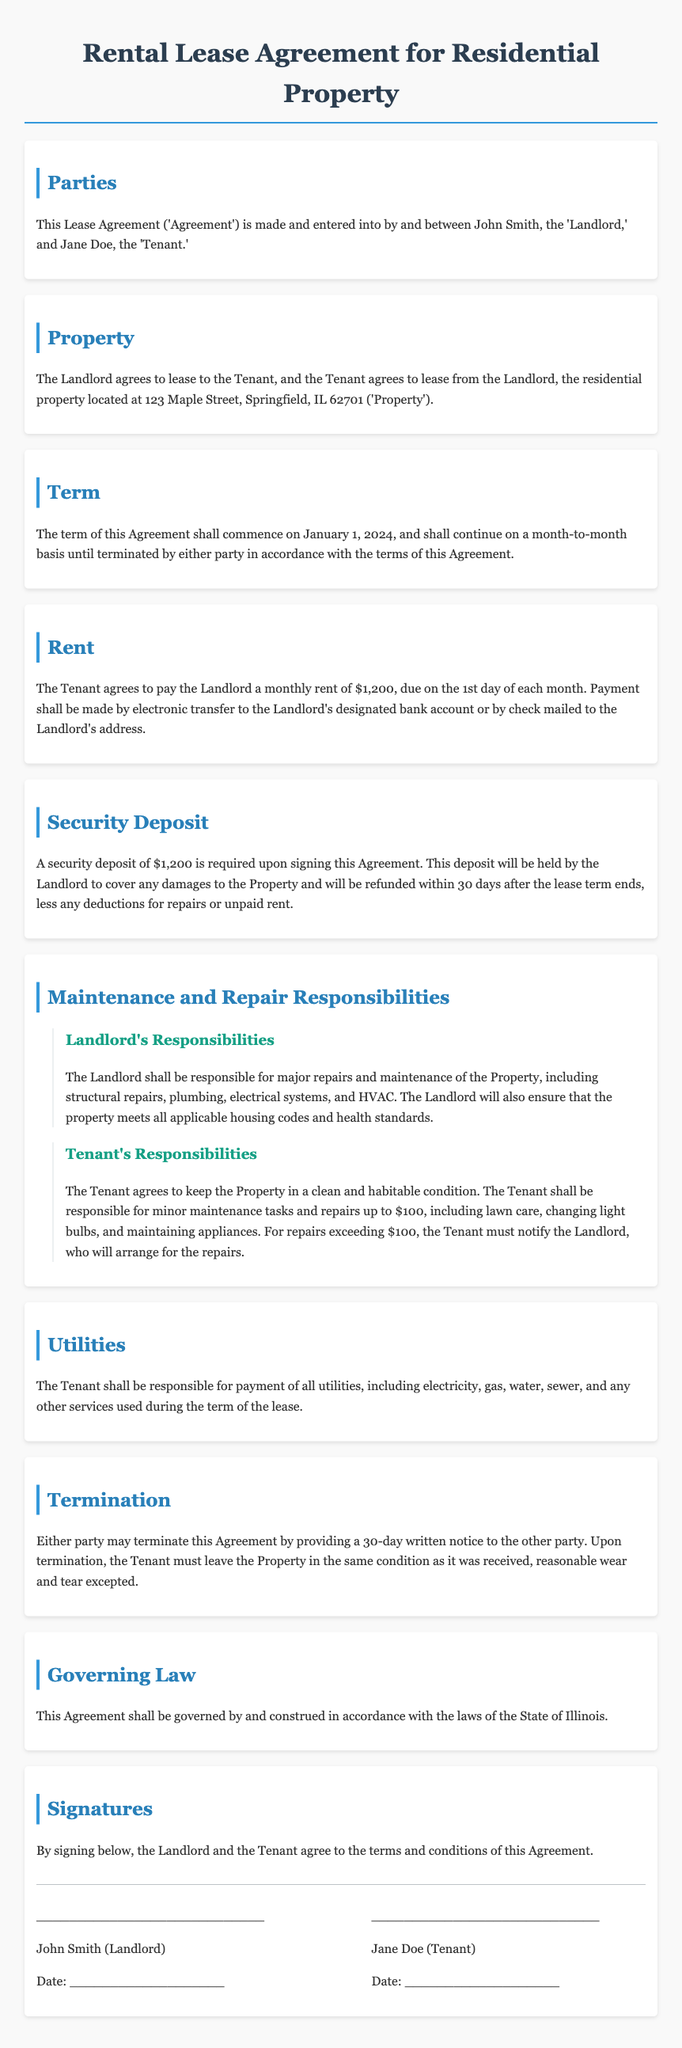What is the rental amount? The rental amount is specified in the Rent section of the document as $1,200.
Answer: $1,200 Who are the parties involved in the agreement? The parties involved are listed in the Parties section as John Smith and Jane Doe.
Answer: John Smith and Jane Doe What is the security deposit amount? The security deposit is outlined in the Security Deposit section as $1,200.
Answer: $1,200 When does the lease commence? The date the lease commences is found in the Term section of the document, stating January 1, 2024.
Answer: January 1, 2024 What must the Tenant notify the Landlord for? The Tenant must notify the Landlord for repairs exceeding $100, according to the Tenant's Responsibilities.
Answer: Repairs exceeding $100 What is the notice period for termination? The termination notice period is mentioned in the Termination section as 30 days.
Answer: 30 days Who is responsible for major repairs? The responsibilities for major repairs are stated to fall under the Landlord’s duties in the Maintenance and Repair Responsibilities section.
Answer: Landlord What will the security deposit cover? The document explains that the security deposit will cover damages to the Property in the Security Deposit section.
Answer: Damages to the Property What style of law governs this Agreement? The governing law is specified in the Governing Law section as the laws of the State of Illinois.
Answer: State of Illinois 